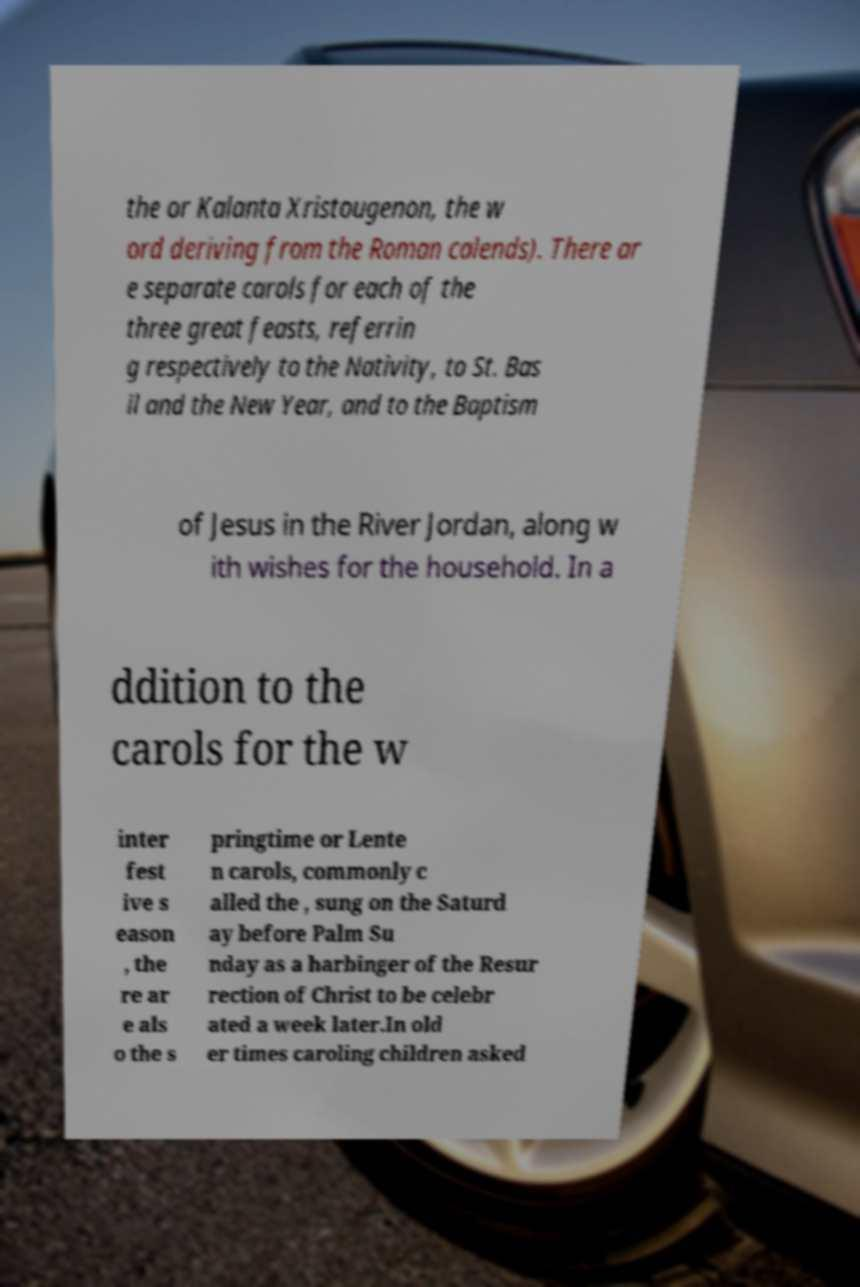Can you read and provide the text displayed in the image?This photo seems to have some interesting text. Can you extract and type it out for me? the or Kalanta Xristougenon, the w ord deriving from the Roman calends). There ar e separate carols for each of the three great feasts, referrin g respectively to the Nativity, to St. Bas il and the New Year, and to the Baptism of Jesus in the River Jordan, along w ith wishes for the household. In a ddition to the carols for the w inter fest ive s eason , the re ar e als o the s pringtime or Lente n carols, commonly c alled the , sung on the Saturd ay before Palm Su nday as a harbinger of the Resur rection of Christ to be celebr ated a week later.In old er times caroling children asked 